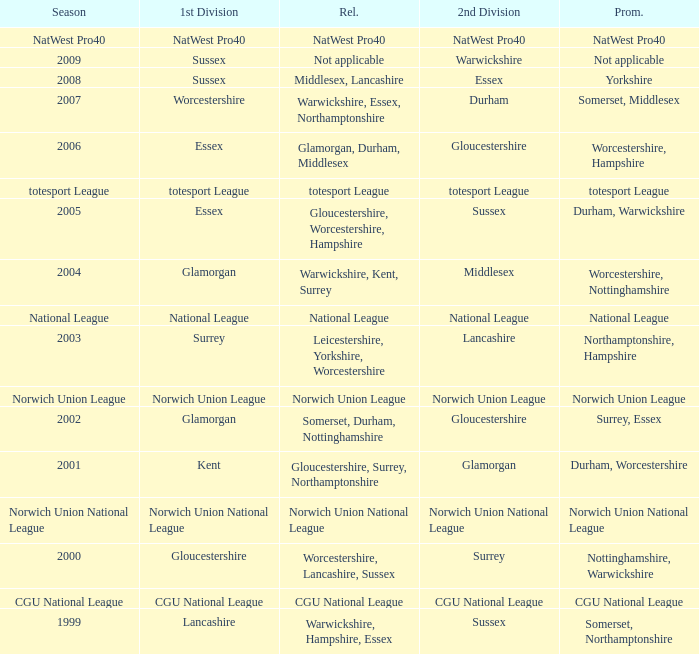What was relegated in the 2006 season? Glamorgan, Durham, Middlesex. 